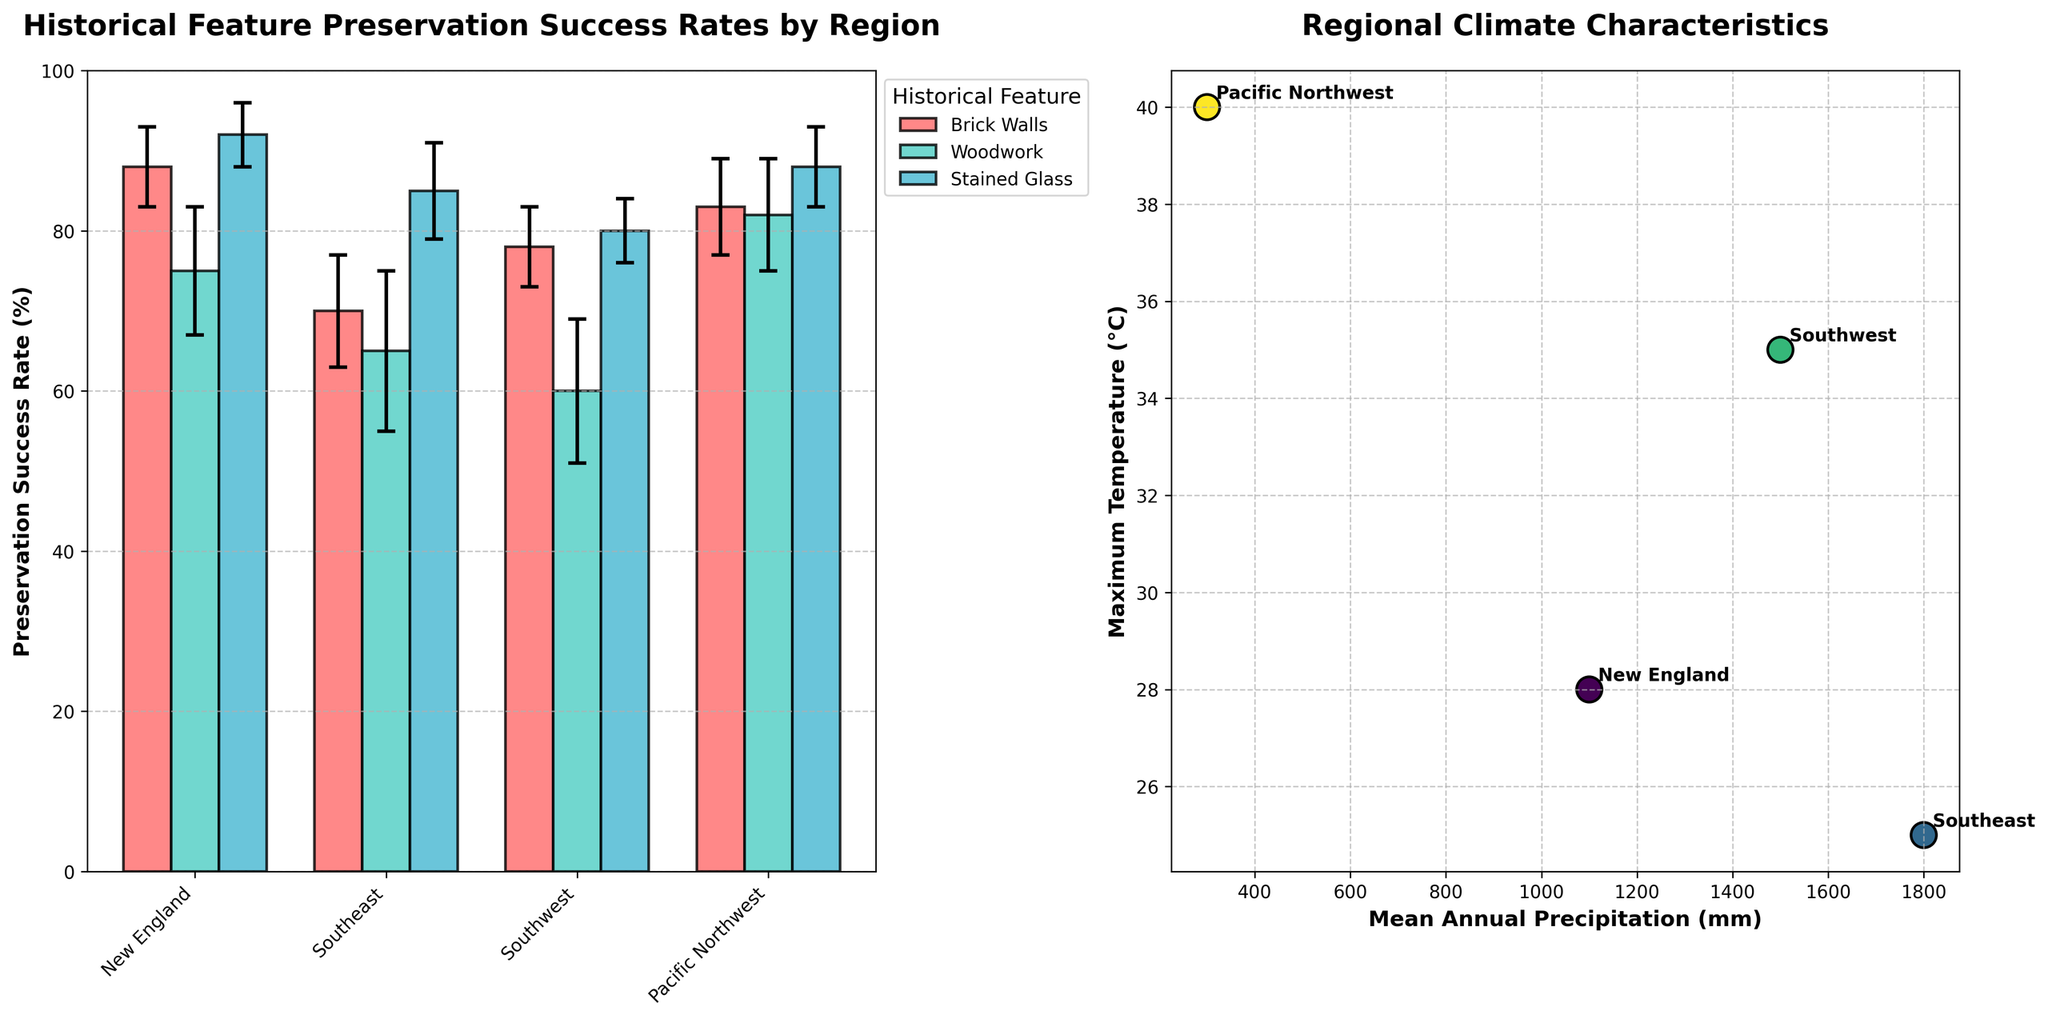What regions are displayed in the bar chart on the left? The regions are listed on the x-axis of the bar chart on the left. They are New England, Southeast, Southwest, and Pacific Northwest.
Answer: New England, Southeast, Southwest, Pacific Northwest What is the highest preservation success rate of brick walls and in which region is this achieved? In the bar chart on the left, the highest bar for brick walls is in the New England region, reaching a success rate of 88%.
Answer: 88%, New England Which historical feature has the lowest preservation success rate in the Southeast region? In the bar chart on the left, look at the bars corresponding to the Southeast region. The lowest bar among the features is for woodwork, with a preservation success rate of 65%.
Answer: Woodwork, 65% How does the preservation success rate of stained glass in the Pacific Northwest compare with that in the Southwest? Compare the two bars for stained glass in the regions of Pacific Northwest and Southwest on the bar chart. Pacific Northwest has a success rate of 88%, and Southwest has 80%.
Answer: Higher, 88% vs. 80% What is the relationship between Mean Annual Precipitation and Maximum Temperature for the regions? The scatter plot on the right shows the relationship. As precipitation increases, there is no clear linear trend with maximum temperature, showing a varied climatic characteristic across regions.
Answer: Varied Which region has the most similar preservation success rate for brick walls and woodwork? In the bar chart on the left, look for regions where the bars for brick walls and woodwork are closest in height. This occurs in the Pacific Northwest, where brick walls have a rates of 83%, and woodwork is 82%.
Answer: Pacific Northwest What is the average preservation success rate of woodwork across all regions? Sum the preservation success rates for woodwork in New England, Southeast, Southwest, and Pacific Northwest, then divide by 4. The rates are 75, 65, 60, and 82. (75 + 65 + 60 + 82) / 4 = 70.5%
Answer: 70.5% Which region has the smallest error margin for stained glass preservation success? In the bar chart on the left, find the smallest error bar among the stained glass success rates. The smallest error margin is for New England and Southwest both at 4%.
Answer: New England, Southwest How does the maximum temperature in the Southeast compare to that in the Pacific Northwest? The scatter plot on the right shows the maximum temperatures. The point for the Southeast is higher on the y-axis compared to the Pacific Northwest, indicating a higher maximum temperature.
Answer: Higher What is the difference in preservation success rate for stained glass between the region with the highest and the lowest success rates? The highest preservation success rate for stained glass is in New England at 92%, and the lowest is in the Southwest at 80%. The difference is 92% - 80% = 12%.
Answer: 12% 